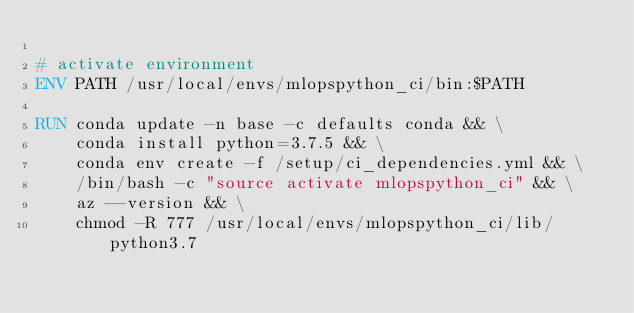Convert code to text. <code><loc_0><loc_0><loc_500><loc_500><_Dockerfile_>
# activate environment
ENV PATH /usr/local/envs/mlopspython_ci/bin:$PATH

RUN conda update -n base -c defaults conda && \
    conda install python=3.7.5 && \
    conda env create -f /setup/ci_dependencies.yml && \
    /bin/bash -c "source activate mlopspython_ci" && \
    az --version && \
    chmod -R 777 /usr/local/envs/mlopspython_ci/lib/python3.7
</code> 